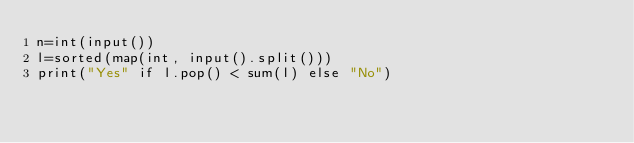<code> <loc_0><loc_0><loc_500><loc_500><_Python_>n=int(input())
l=sorted(map(int, input().split()))
print("Yes" if l.pop() < sum(l) else "No")
</code> 